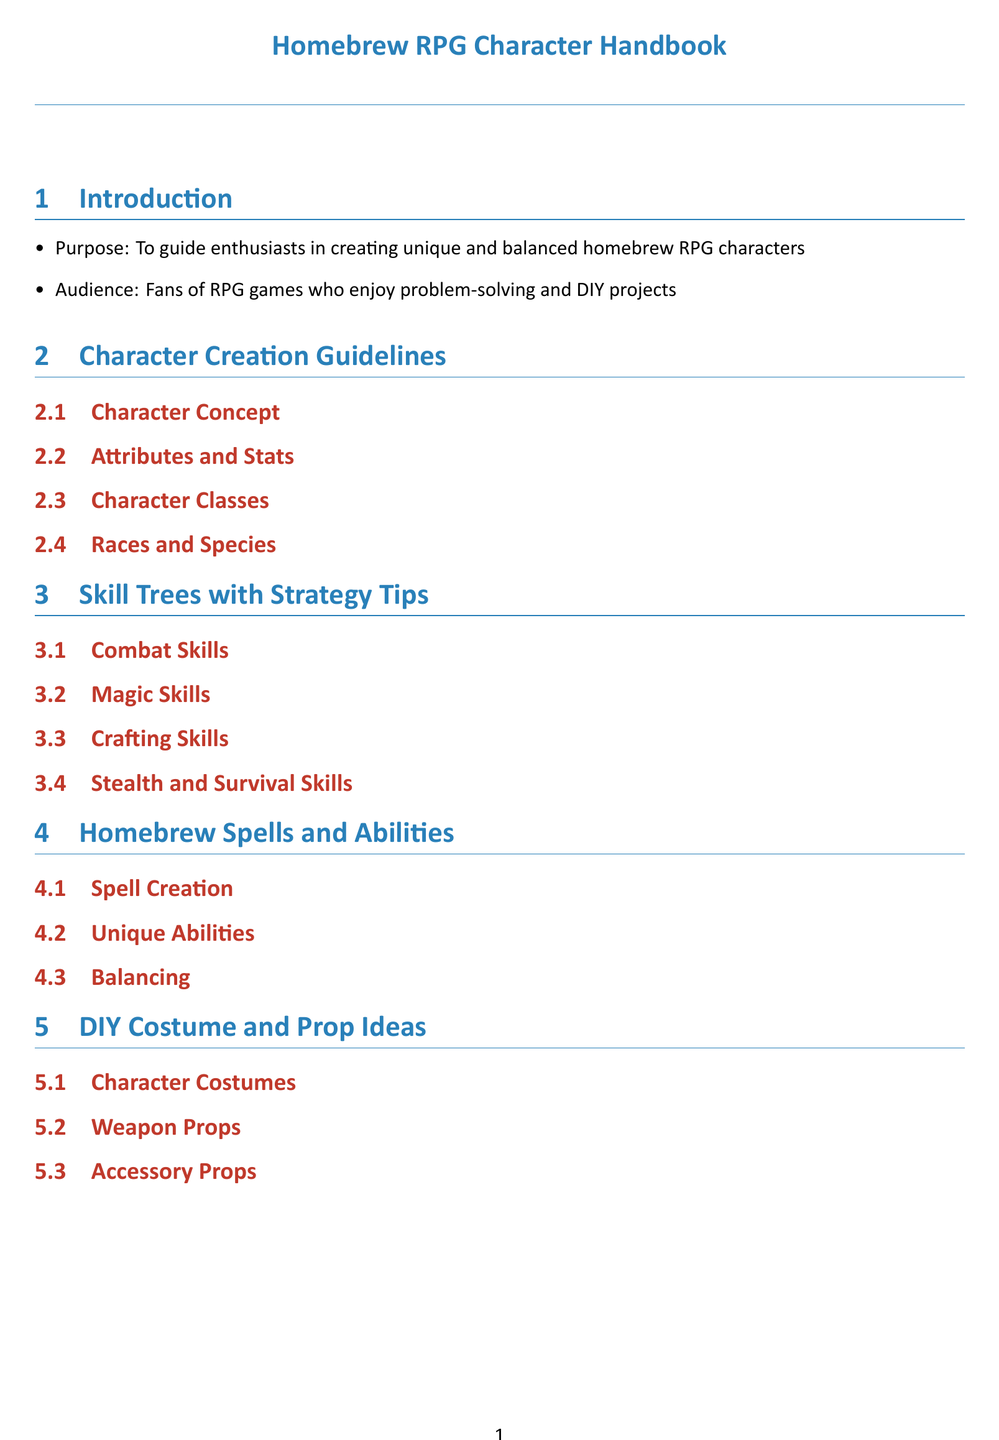What is the purpose of the handbook? The purpose is to guide enthusiasts in creating unique and balanced homebrew RPG characters.
Answer: To guide enthusiasts in creating unique and balanced homebrew RPG characters Who is the target audience? The audience is specified as fans of RPG games who enjoy problem-solving and DIY projects.
Answer: Fans of RPG games who enjoy problem-solving and DIY projects How many main sections are listed in the table of contents? The number of main sections can be counted from the table of contents. There are four main sections.
Answer: Four What is the first subsection under "Character Creation Guidelines"? The first subsection is identified from the list provided under "Character Creation Guidelines".
Answer: Character Concept What type of skills are addressed in the "Skill Trees with Strategy Tips" section? The section focuses on various skills that can be categorized under combat, magic, crafting, and stealth/survival.
Answer: Combat Skills, Magic Skills, Crafting Skills, Stealth and Survival Skills What does the "DIY Costume and Prop Ideas" section include? The section includes ideas for character costumes, weapon props, and accessory props.
Answer: Character Costumes, Weapon Props, Accessory Props What is a key aspect of the "Homebrew Spells and Abilities" section mentioned? A key aspect involved in the section is called balancing, which is important for gameplay.
Answer: Balancing What visual element distinguishes the sections in the document? The sections are visually distinguished by colored titles and a horizontal line (titlerule) following the section title.
Answer: Colored titles and titlerule 